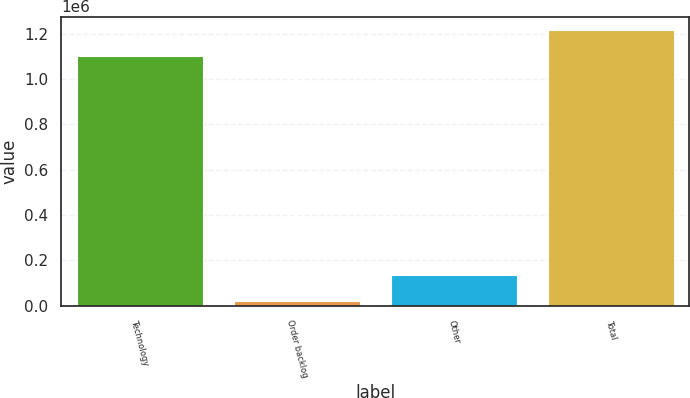<chart> <loc_0><loc_0><loc_500><loc_500><bar_chart><fcel>Technology<fcel>Order backlog<fcel>Other<fcel>Total<nl><fcel>1.10032e+06<fcel>19501<fcel>133856<fcel>1.21467e+06<nl></chart> 